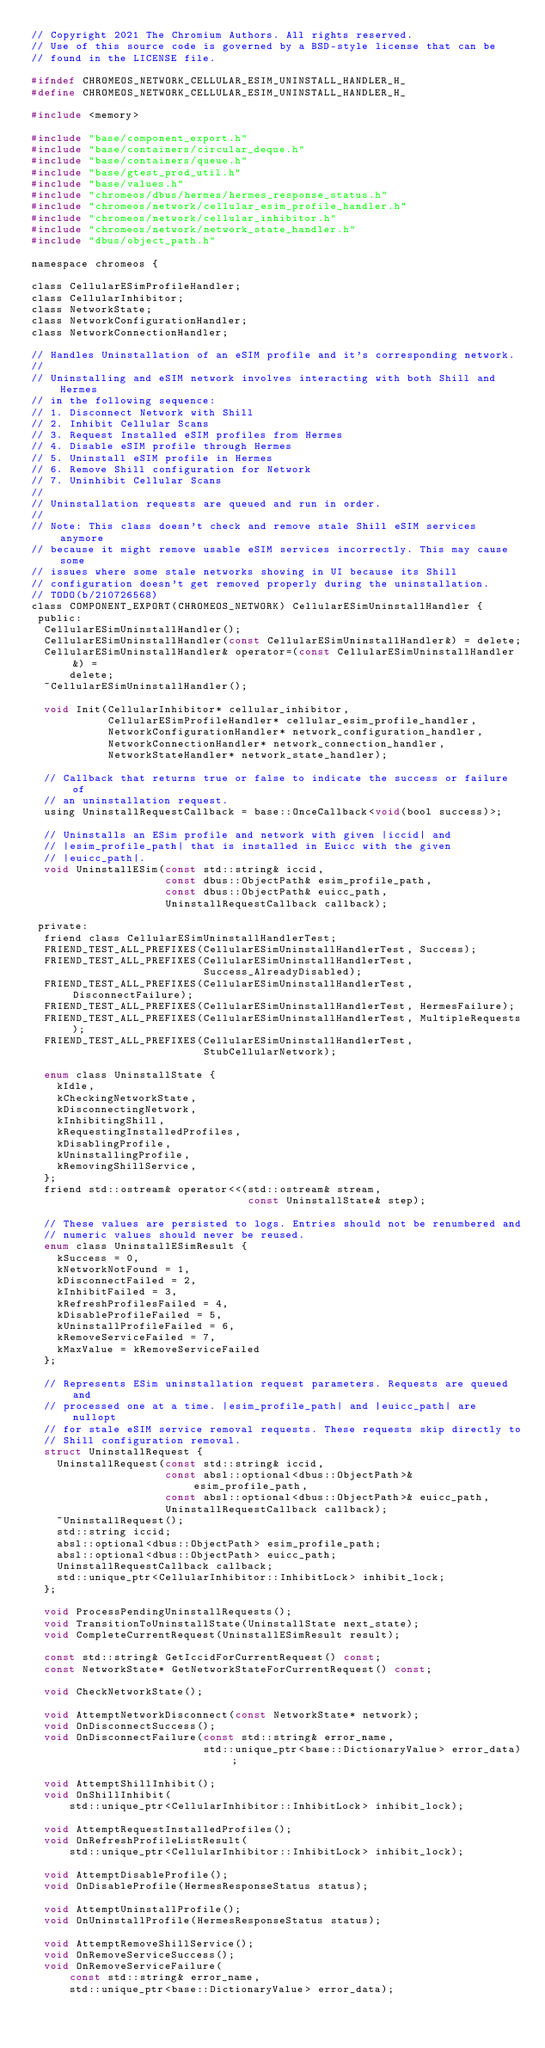<code> <loc_0><loc_0><loc_500><loc_500><_C_>// Copyright 2021 The Chromium Authors. All rights reserved.
// Use of this source code is governed by a BSD-style license that can be
// found in the LICENSE file.

#ifndef CHROMEOS_NETWORK_CELLULAR_ESIM_UNINSTALL_HANDLER_H_
#define CHROMEOS_NETWORK_CELLULAR_ESIM_UNINSTALL_HANDLER_H_

#include <memory>

#include "base/component_export.h"
#include "base/containers/circular_deque.h"
#include "base/containers/queue.h"
#include "base/gtest_prod_util.h"
#include "base/values.h"
#include "chromeos/dbus/hermes/hermes_response_status.h"
#include "chromeos/network/cellular_esim_profile_handler.h"
#include "chromeos/network/cellular_inhibitor.h"
#include "chromeos/network/network_state_handler.h"
#include "dbus/object_path.h"

namespace chromeos {

class CellularESimProfileHandler;
class CellularInhibitor;
class NetworkState;
class NetworkConfigurationHandler;
class NetworkConnectionHandler;

// Handles Uninstallation of an eSIM profile and it's corresponding network.
//
// Uninstalling and eSIM network involves interacting with both Shill and Hermes
// in the following sequence:
// 1. Disconnect Network with Shill
// 2. Inhibit Cellular Scans
// 3. Request Installed eSIM profiles from Hermes
// 4. Disable eSIM profile through Hermes
// 5. Uninstall eSIM profile in Hermes
// 6. Remove Shill configuration for Network
// 7. Uninhibit Cellular Scans
//
// Uninstallation requests are queued and run in order.
//
// Note: This class doesn't check and remove stale Shill eSIM services anymore
// because it might remove usable eSIM services incorrectly. This may cause some
// issues where some stale networks showing in UI because its Shill
// configuration doesn't get removed properly during the uninstallation.
// TODO(b/210726568)
class COMPONENT_EXPORT(CHROMEOS_NETWORK) CellularESimUninstallHandler {
 public:
  CellularESimUninstallHandler();
  CellularESimUninstallHandler(const CellularESimUninstallHandler&) = delete;
  CellularESimUninstallHandler& operator=(const CellularESimUninstallHandler&) =
      delete;
  ~CellularESimUninstallHandler();

  void Init(CellularInhibitor* cellular_inhibitor,
            CellularESimProfileHandler* cellular_esim_profile_handler,
            NetworkConfigurationHandler* network_configuration_handler,
            NetworkConnectionHandler* network_connection_handler,
            NetworkStateHandler* network_state_handler);

  // Callback that returns true or false to indicate the success or failure of
  // an uninstallation request.
  using UninstallRequestCallback = base::OnceCallback<void(bool success)>;

  // Uninstalls an ESim profile and network with given |iccid| and
  // |esim_profile_path| that is installed in Euicc with the given
  // |euicc_path|.
  void UninstallESim(const std::string& iccid,
                     const dbus::ObjectPath& esim_profile_path,
                     const dbus::ObjectPath& euicc_path,
                     UninstallRequestCallback callback);

 private:
  friend class CellularESimUninstallHandlerTest;
  FRIEND_TEST_ALL_PREFIXES(CellularESimUninstallHandlerTest, Success);
  FRIEND_TEST_ALL_PREFIXES(CellularESimUninstallHandlerTest,
                           Success_AlreadyDisabled);
  FRIEND_TEST_ALL_PREFIXES(CellularESimUninstallHandlerTest, DisconnectFailure);
  FRIEND_TEST_ALL_PREFIXES(CellularESimUninstallHandlerTest, HermesFailure);
  FRIEND_TEST_ALL_PREFIXES(CellularESimUninstallHandlerTest, MultipleRequests);
  FRIEND_TEST_ALL_PREFIXES(CellularESimUninstallHandlerTest,
                           StubCellularNetwork);

  enum class UninstallState {
    kIdle,
    kCheckingNetworkState,
    kDisconnectingNetwork,
    kInhibitingShill,
    kRequestingInstalledProfiles,
    kDisablingProfile,
    kUninstallingProfile,
    kRemovingShillService,
  };
  friend std::ostream& operator<<(std::ostream& stream,
                                  const UninstallState& step);

  // These values are persisted to logs. Entries should not be renumbered and
  // numeric values should never be reused.
  enum class UninstallESimResult {
    kSuccess = 0,
    kNetworkNotFound = 1,
    kDisconnectFailed = 2,
    kInhibitFailed = 3,
    kRefreshProfilesFailed = 4,
    kDisableProfileFailed = 5,
    kUninstallProfileFailed = 6,
    kRemoveServiceFailed = 7,
    kMaxValue = kRemoveServiceFailed
  };

  // Represents ESim uninstallation request parameters. Requests are queued and
  // processed one at a time. |esim_profile_path| and |euicc_path| are nullopt
  // for stale eSIM service removal requests. These requests skip directly to
  // Shill configuration removal.
  struct UninstallRequest {
    UninstallRequest(const std::string& iccid,
                     const absl::optional<dbus::ObjectPath>& esim_profile_path,
                     const absl::optional<dbus::ObjectPath>& euicc_path,
                     UninstallRequestCallback callback);
    ~UninstallRequest();
    std::string iccid;
    absl::optional<dbus::ObjectPath> esim_profile_path;
    absl::optional<dbus::ObjectPath> euicc_path;
    UninstallRequestCallback callback;
    std::unique_ptr<CellularInhibitor::InhibitLock> inhibit_lock;
  };

  void ProcessPendingUninstallRequests();
  void TransitionToUninstallState(UninstallState next_state);
  void CompleteCurrentRequest(UninstallESimResult result);

  const std::string& GetIccidForCurrentRequest() const;
  const NetworkState* GetNetworkStateForCurrentRequest() const;

  void CheckNetworkState();

  void AttemptNetworkDisconnect(const NetworkState* network);
  void OnDisconnectSuccess();
  void OnDisconnectFailure(const std::string& error_name,
                           std::unique_ptr<base::DictionaryValue> error_data);

  void AttemptShillInhibit();
  void OnShillInhibit(
      std::unique_ptr<CellularInhibitor::InhibitLock> inhibit_lock);

  void AttemptRequestInstalledProfiles();
  void OnRefreshProfileListResult(
      std::unique_ptr<CellularInhibitor::InhibitLock> inhibit_lock);

  void AttemptDisableProfile();
  void OnDisableProfile(HermesResponseStatus status);

  void AttemptUninstallProfile();
  void OnUninstallProfile(HermesResponseStatus status);

  void AttemptRemoveShillService();
  void OnRemoveServiceSuccess();
  void OnRemoveServiceFailure(
      const std::string& error_name,
      std::unique_ptr<base::DictionaryValue> error_data);
</code> 